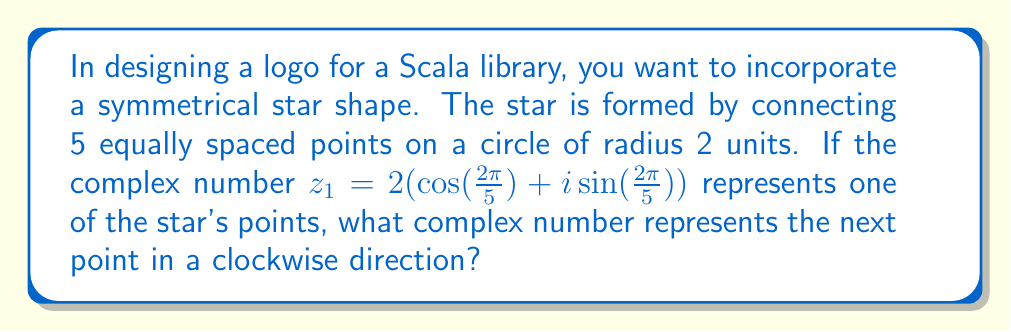Teach me how to tackle this problem. Let's approach this step-by-step:

1) First, we need to understand what $z_1$ represents. It's a point on a circle with radius 2, at an angle of $\frac{2\pi}{5}$ radians from the positive real axis.

2) The five points of the star are equally spaced around the circle. This means each point is rotated by $\frac{2\pi}{5}$ radians from the previous one.

3) To move clockwise to the next point, we need to rotate $z_1$ by $\frac{2\pi}{5}$ radians in the negative direction (clockwise).

4) In complex analysis, rotation by an angle $\theta$ is achieved by multiplying by $e^{-i\theta}$. In this case, $\theta = \frac{2\pi}{5}$.

5) So, the next point $z_2$ can be found by:

   $z_2 = z_1 \cdot e^{-i\frac{2\pi}{5}}$

6) Let's expand this:
   
   $z_2 = 2(\cos(\frac{2\pi}{5}) + i\sin(\frac{2\pi}{5})) \cdot (\cos(-\frac{2\pi}{5}) + i\sin(-\frac{2\pi}{5}))$

7) Using the properties of complex multiplication:

   $z_2 = 2[\cos(\frac{2\pi}{5})\cos(-\frac{2\pi}{5}) - \sin(\frac{2\pi}{5})\sin(-\frac{2\pi}{5}) + i(\sin(\frac{2\pi}{5})\cos(-\frac{2\pi}{5}) + \cos(\frac{2\pi}{5})\sin(-\frac{2\pi}{5}))]$

8) Simplify using trigonometric sum formulas:

   $z_2 = 2[\cos(\frac{4\pi}{5}) + i\sin(\frac{4\pi}{5})]$

This is the complex number representing the next point of the star in a clockwise direction.
Answer: $z_2 = 2(\cos(\frac{4\pi}{5}) + i\sin(\frac{4\pi}{5}))$ 